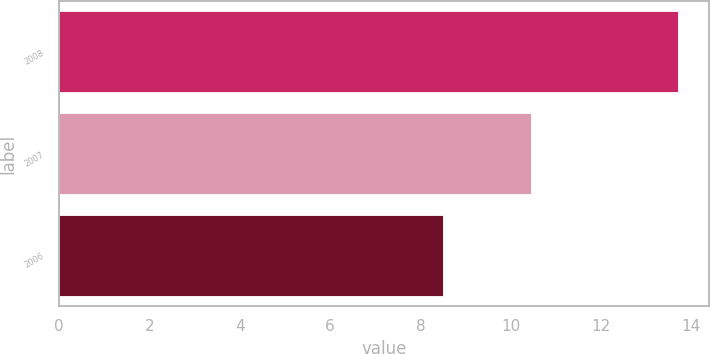Convert chart to OTSL. <chart><loc_0><loc_0><loc_500><loc_500><bar_chart><fcel>2008<fcel>2007<fcel>2006<nl><fcel>13.71<fcel>10.46<fcel>8.51<nl></chart> 